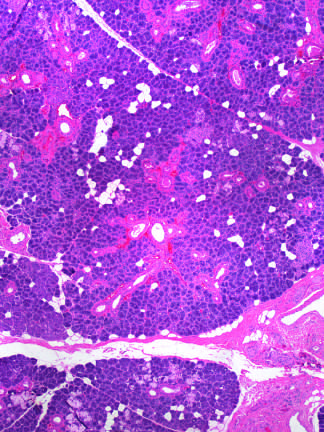what is produced by radiation therapy of the neck region?
Answer the question using a single word or phrase. Vascular changes and fibrosis of salivary glands 